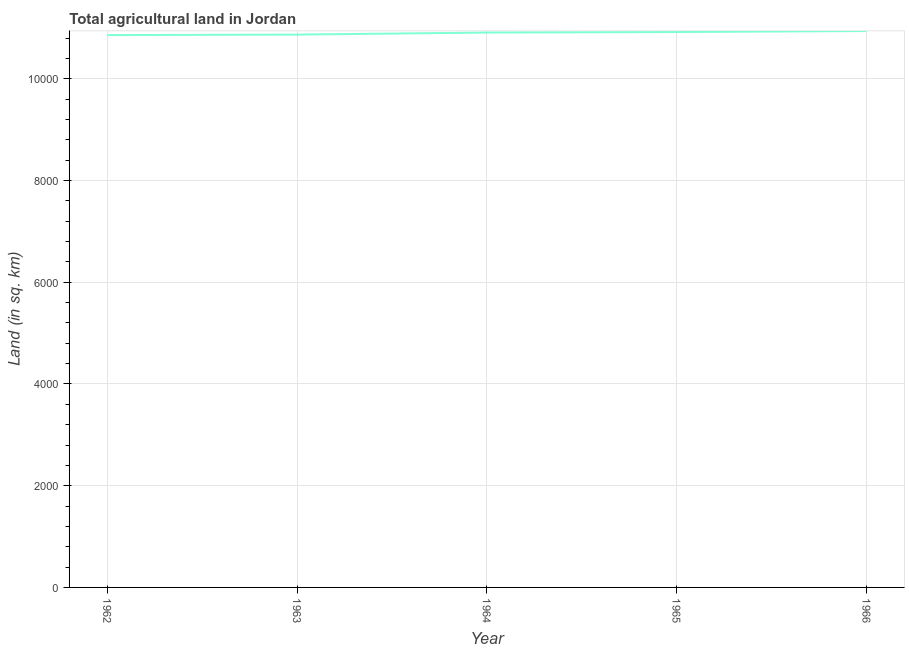What is the agricultural land in 1966?
Provide a short and direct response. 1.09e+04. Across all years, what is the maximum agricultural land?
Your answer should be very brief. 1.09e+04. Across all years, what is the minimum agricultural land?
Give a very brief answer. 1.09e+04. In which year was the agricultural land maximum?
Keep it short and to the point. 1966. In which year was the agricultural land minimum?
Your answer should be compact. 1962. What is the sum of the agricultural land?
Provide a short and direct response. 5.45e+04. What is the difference between the agricultural land in 1965 and 1966?
Your response must be concise. -20. What is the average agricultural land per year?
Your answer should be very brief. 1.09e+04. What is the median agricultural land?
Ensure brevity in your answer.  1.09e+04. Do a majority of the years between 1964 and 1962 (inclusive) have agricultural land greater than 1200 sq. km?
Provide a succinct answer. No. What is the ratio of the agricultural land in 1962 to that in 1966?
Offer a very short reply. 0.99. What is the difference between the highest and the second highest agricultural land?
Make the answer very short. 20. Is the sum of the agricultural land in 1962 and 1966 greater than the maximum agricultural land across all years?
Your answer should be very brief. Yes. What is the difference between the highest and the lowest agricultural land?
Your answer should be very brief. 80. How many years are there in the graph?
Give a very brief answer. 5. What is the title of the graph?
Your answer should be compact. Total agricultural land in Jordan. What is the label or title of the X-axis?
Offer a terse response. Year. What is the label or title of the Y-axis?
Keep it short and to the point. Land (in sq. km). What is the Land (in sq. km) of 1962?
Keep it short and to the point. 1.09e+04. What is the Land (in sq. km) in 1963?
Provide a succinct answer. 1.09e+04. What is the Land (in sq. km) in 1964?
Ensure brevity in your answer.  1.09e+04. What is the Land (in sq. km) of 1965?
Your response must be concise. 1.09e+04. What is the Land (in sq. km) in 1966?
Your response must be concise. 1.09e+04. What is the difference between the Land (in sq. km) in 1962 and 1963?
Ensure brevity in your answer.  -10. What is the difference between the Land (in sq. km) in 1962 and 1964?
Ensure brevity in your answer.  -50. What is the difference between the Land (in sq. km) in 1962 and 1965?
Offer a very short reply. -60. What is the difference between the Land (in sq. km) in 1962 and 1966?
Your answer should be very brief. -80. What is the difference between the Land (in sq. km) in 1963 and 1964?
Your response must be concise. -40. What is the difference between the Land (in sq. km) in 1963 and 1966?
Provide a succinct answer. -70. What is the difference between the Land (in sq. km) in 1964 and 1965?
Offer a very short reply. -10. What is the difference between the Land (in sq. km) in 1965 and 1966?
Provide a succinct answer. -20. What is the ratio of the Land (in sq. km) in 1962 to that in 1963?
Provide a short and direct response. 1. What is the ratio of the Land (in sq. km) in 1962 to that in 1964?
Your response must be concise. 0.99. What is the ratio of the Land (in sq. km) in 1962 to that in 1965?
Ensure brevity in your answer.  0.99. What is the ratio of the Land (in sq. km) in 1963 to that in 1964?
Keep it short and to the point. 1. What is the ratio of the Land (in sq. km) in 1964 to that in 1965?
Offer a terse response. 1. 